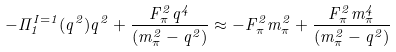Convert formula to latex. <formula><loc_0><loc_0><loc_500><loc_500>- \Pi _ { 1 } ^ { I = 1 } ( q ^ { 2 } ) q ^ { 2 } + \frac { F _ { \pi } ^ { 2 } q ^ { 4 } } { ( m _ { \pi } ^ { 2 } - q ^ { 2 } ) } \approx - F _ { \pi } ^ { 2 } m _ { \pi } ^ { 2 } + \frac { F _ { \pi } ^ { 2 } m _ { \pi } ^ { 4 } } { ( m _ { \pi } ^ { 2 } - q ^ { 2 } ) }</formula> 